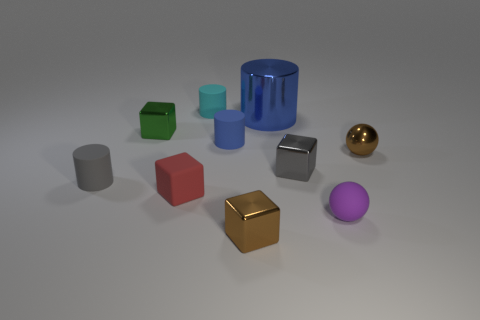Subtract all blue rubber cylinders. How many cylinders are left? 3 Subtract 1 spheres. How many spheres are left? 1 Subtract all blocks. How many objects are left? 6 Subtract all cyan cylinders. How many yellow spheres are left? 0 Subtract all tiny brown metal spheres. Subtract all brown metal spheres. How many objects are left? 8 Add 6 small gray rubber cylinders. How many small gray rubber cylinders are left? 7 Add 7 tiny cyan cylinders. How many tiny cyan cylinders exist? 8 Subtract all purple balls. How many balls are left? 1 Subtract 1 red cubes. How many objects are left? 9 Subtract all yellow cubes. Subtract all purple balls. How many cubes are left? 4 